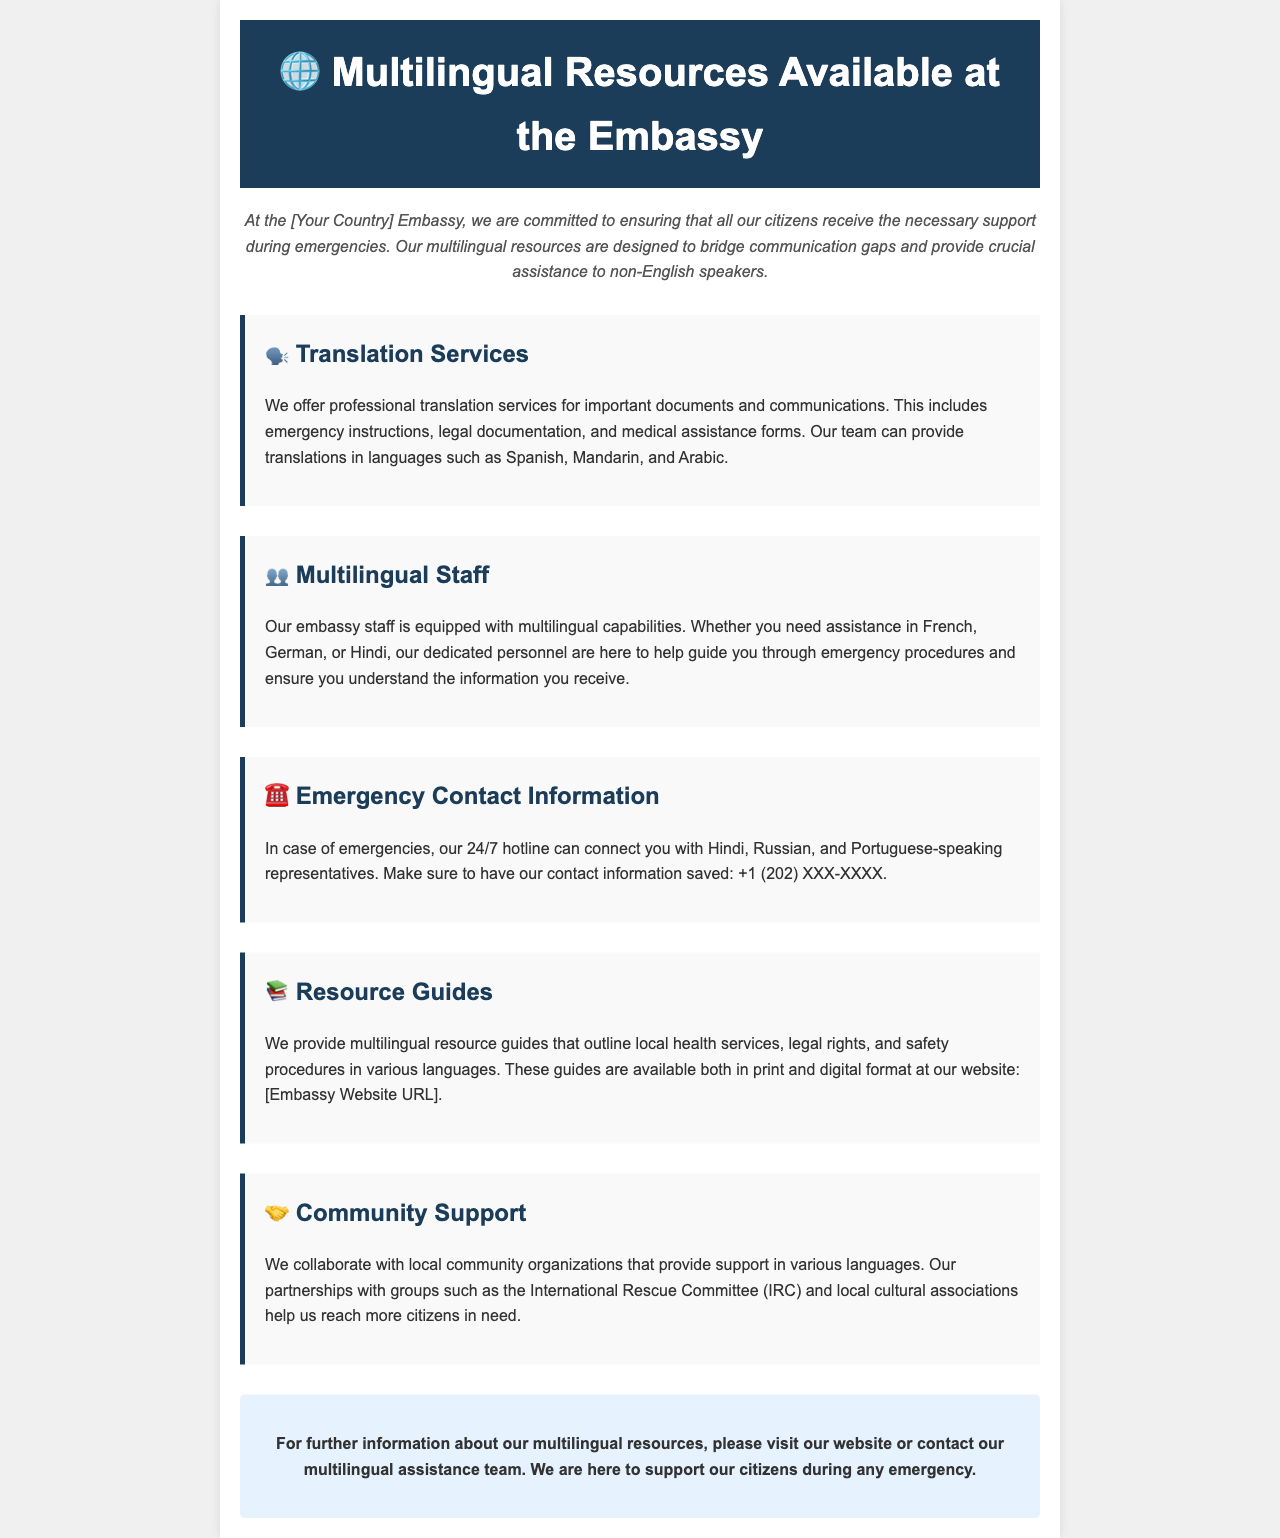What languages are offered for translation services? The document lists Spanish, Mandarin, and Arabic as the languages for translation services.
Answer: Spanish, Mandarin, Arabic What is the contact information for the emergency hotline? The emergency contact information includes a phone number format mentioned in the document: +1 (202) XXX-XXXX.
Answer: +1 (202) XXX-XXXX Which community organization is mentioned in collaboration with the embassy? The document mentions the International Rescue Committee (IRC) as a partner organization.
Answer: International Rescue Committee (IRC) What languages can representatives speak on the 24/7 hotline? The document states that Hindi, Russian, and Portuguese-speaking representatives are available.
Answer: Hindi, Russian, Portuguese What type of guides does the embassy provide? The embassy provides multilingual resource guides that outline health services, legal rights, and safety procedures.
Answer: Resource guides What is the purpose of the multilingual resources? The multilingual resources are designed to bridge communication gaps and provide crucial assistance during emergencies.
Answer: Bridge communication gaps Who are the embassy staff equipped to assist? The embassy staff is equipped to assist citizens who may need support in French, German, or Hindi.
Answer: French, German, Hindi What is the primary commitment of the [Your Country] Embassy? The primary commitment of the embassy is to ensure that all citizens receive necessary support during emergencies.
Answer: Ensure necessary support 